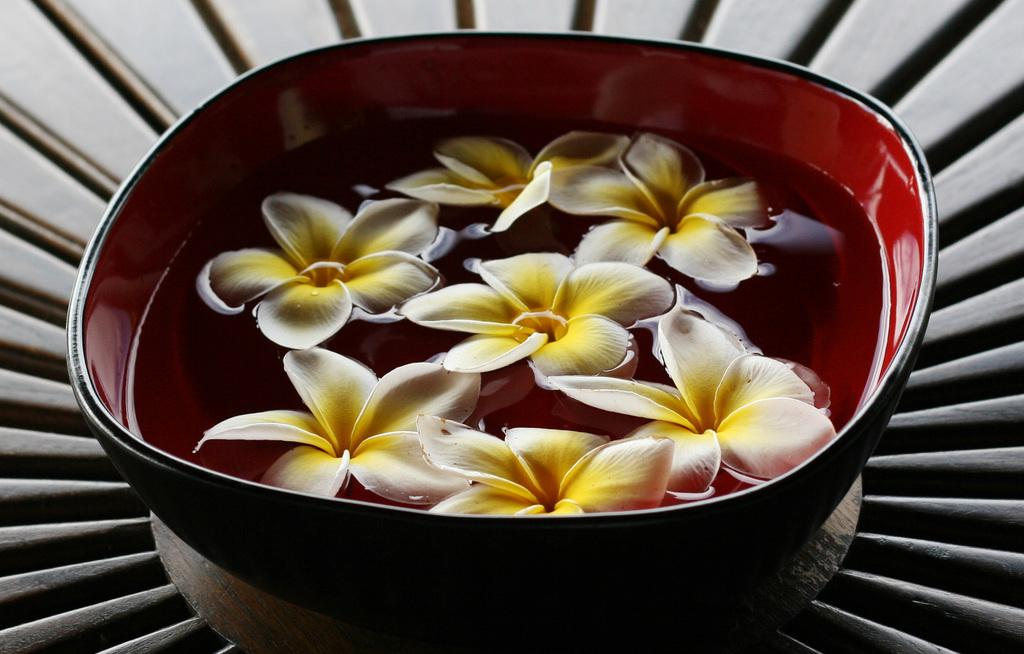What is in the bowl that is visible in the image? The bowl contains flowers in the image. What is the liquid substance in the bowl? There is water in the bowl. Where is the bowl located in the image? The bowl is placed on a table. What material is the table made of? The table is made of wood. How many degrees does the tail of the flower have in the image? There is no flower with a tail present in the image. 